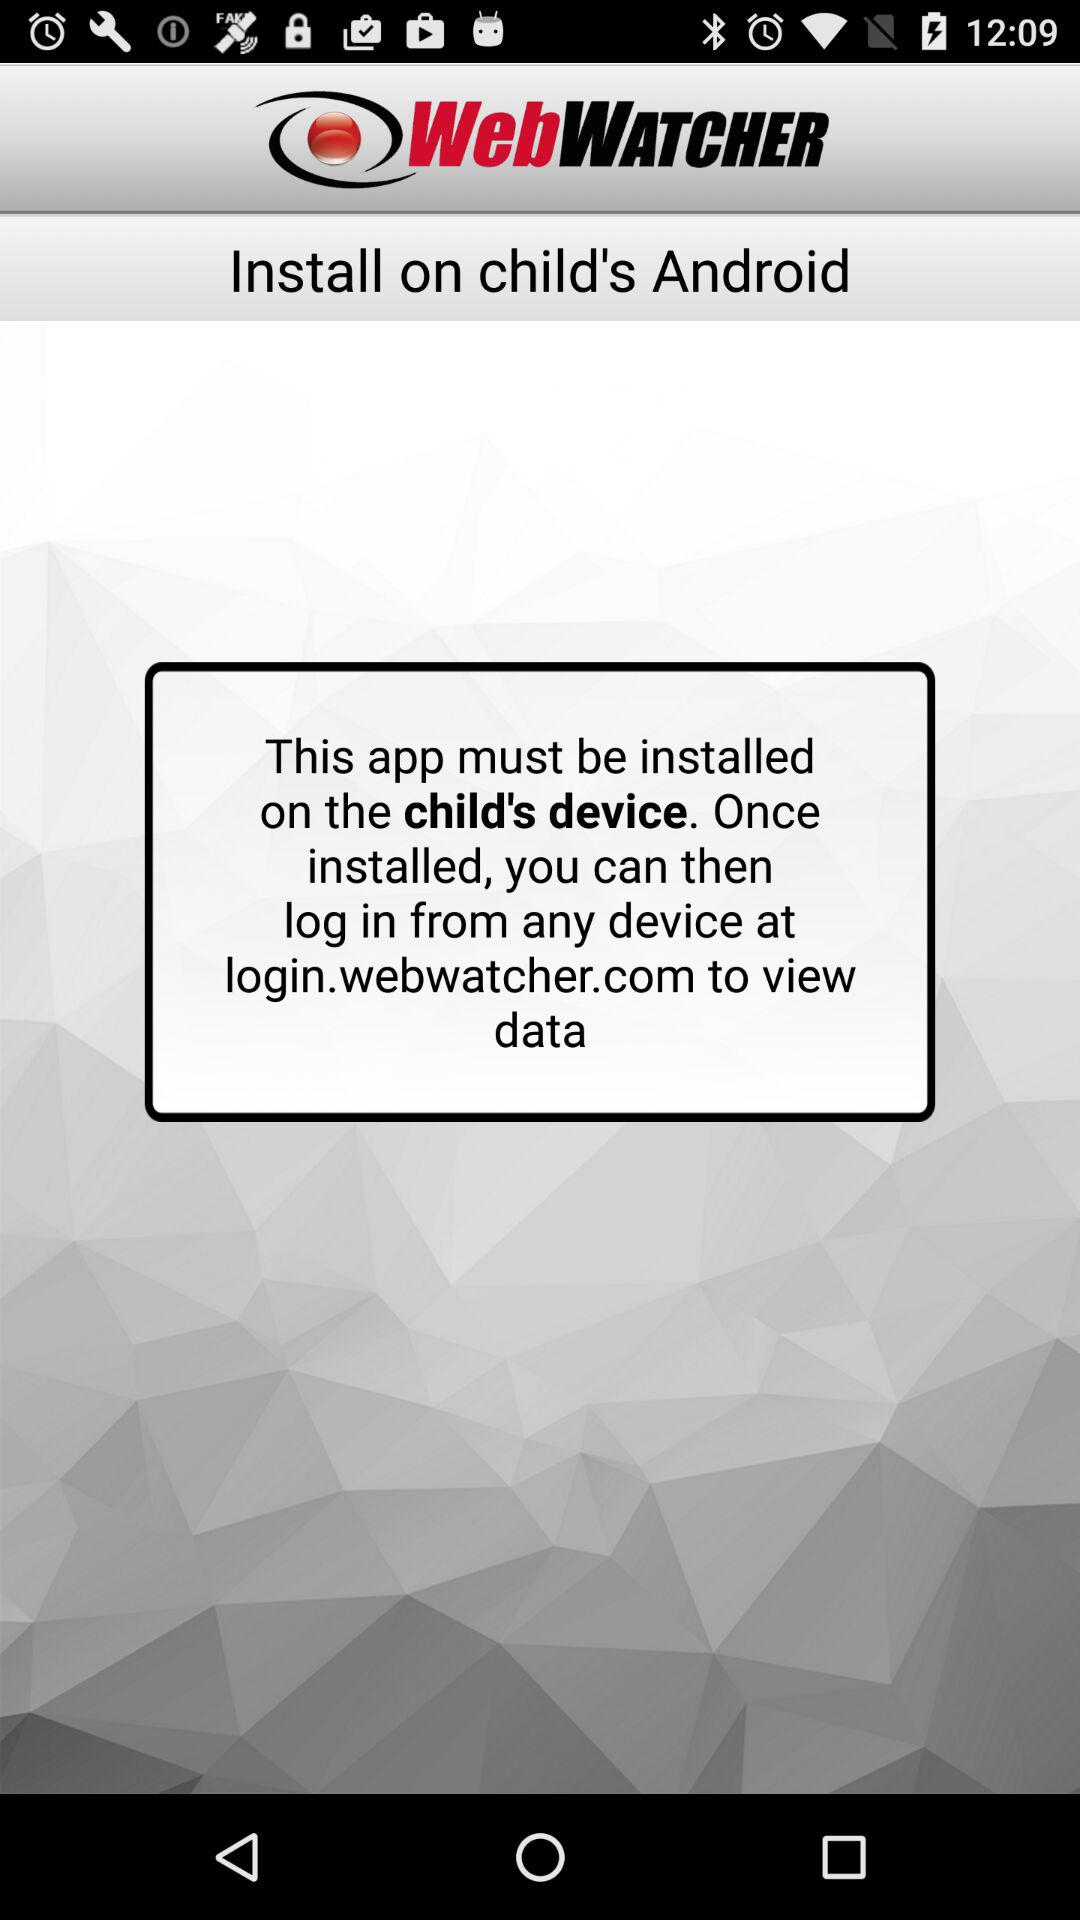Where can I log in to see the data? You can log in at login.webwatcher.com. 